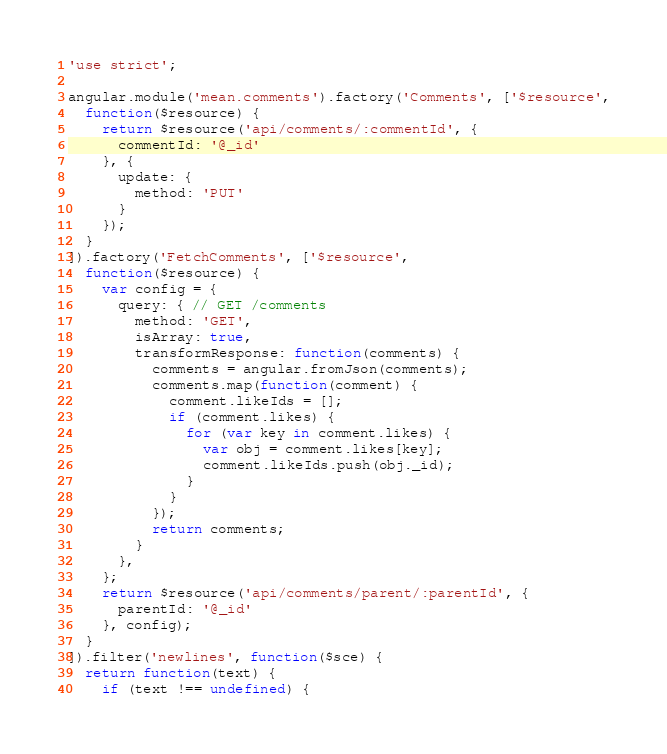<code> <loc_0><loc_0><loc_500><loc_500><_JavaScript_>'use strict';

angular.module('mean.comments').factory('Comments', ['$resource',
  function($resource) {
    return $resource('api/comments/:commentId', {
      commentId: '@_id'
    }, {
      update: {
        method: 'PUT'
      }
    });
  }
]).factory('FetchComments', ['$resource',
  function($resource) {
    var config = {
      query: { // GET /comments
        method: 'GET',
        isArray: true,
        transformResponse: function(comments) {
          comments = angular.fromJson(comments);
          comments.map(function(comment) {
            comment.likeIds = [];
            if (comment.likes) {
              for (var key in comment.likes) {
                var obj = comment.likes[key];
                comment.likeIds.push(obj._id);
              }
            }
          });
          return comments;
        }
      },
    };
    return $resource('api/comments/parent/:parentId', {
      parentId: '@_id'
    }, config);
  }
]).filter('newlines', function($sce) {
  return function(text) {
    if (text !== undefined) {</code> 